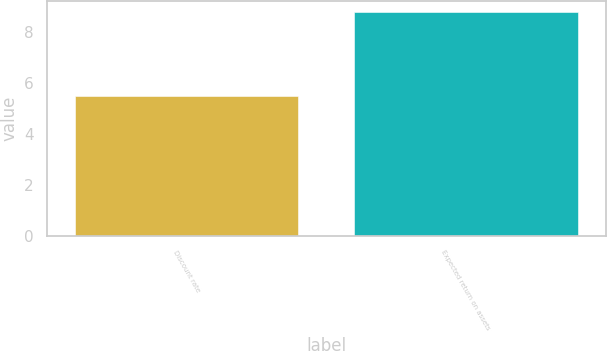<chart> <loc_0><loc_0><loc_500><loc_500><bar_chart><fcel>Discount rate<fcel>Expected return on assets<nl><fcel>5.47<fcel>8.75<nl></chart> 